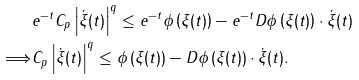<formula> <loc_0><loc_0><loc_500><loc_500>& e ^ { - t } C _ { p } \left | \dot { \xi } ( t ) \right | ^ { q } \leq e ^ { - t } \phi \left ( \xi ( t ) \right ) - e ^ { - t } D \phi \left ( \xi ( t ) \right ) \cdot \dot { \xi } ( t ) \\ \Longrightarrow & C _ { p } \left | \dot { \xi } ( t ) \right | ^ { q } \leq \phi \left ( \xi ( t ) \right ) - D \phi \left ( \xi ( t ) \right ) \cdot \dot { \xi } ( t ) .</formula> 